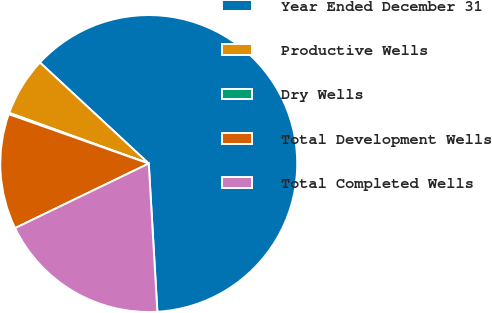Convert chart. <chart><loc_0><loc_0><loc_500><loc_500><pie_chart><fcel>Year Ended December 31<fcel>Productive Wells<fcel>Dry Wells<fcel>Total Development Wells<fcel>Total Completed Wells<nl><fcel>62.17%<fcel>6.36%<fcel>0.15%<fcel>12.56%<fcel>18.76%<nl></chart> 